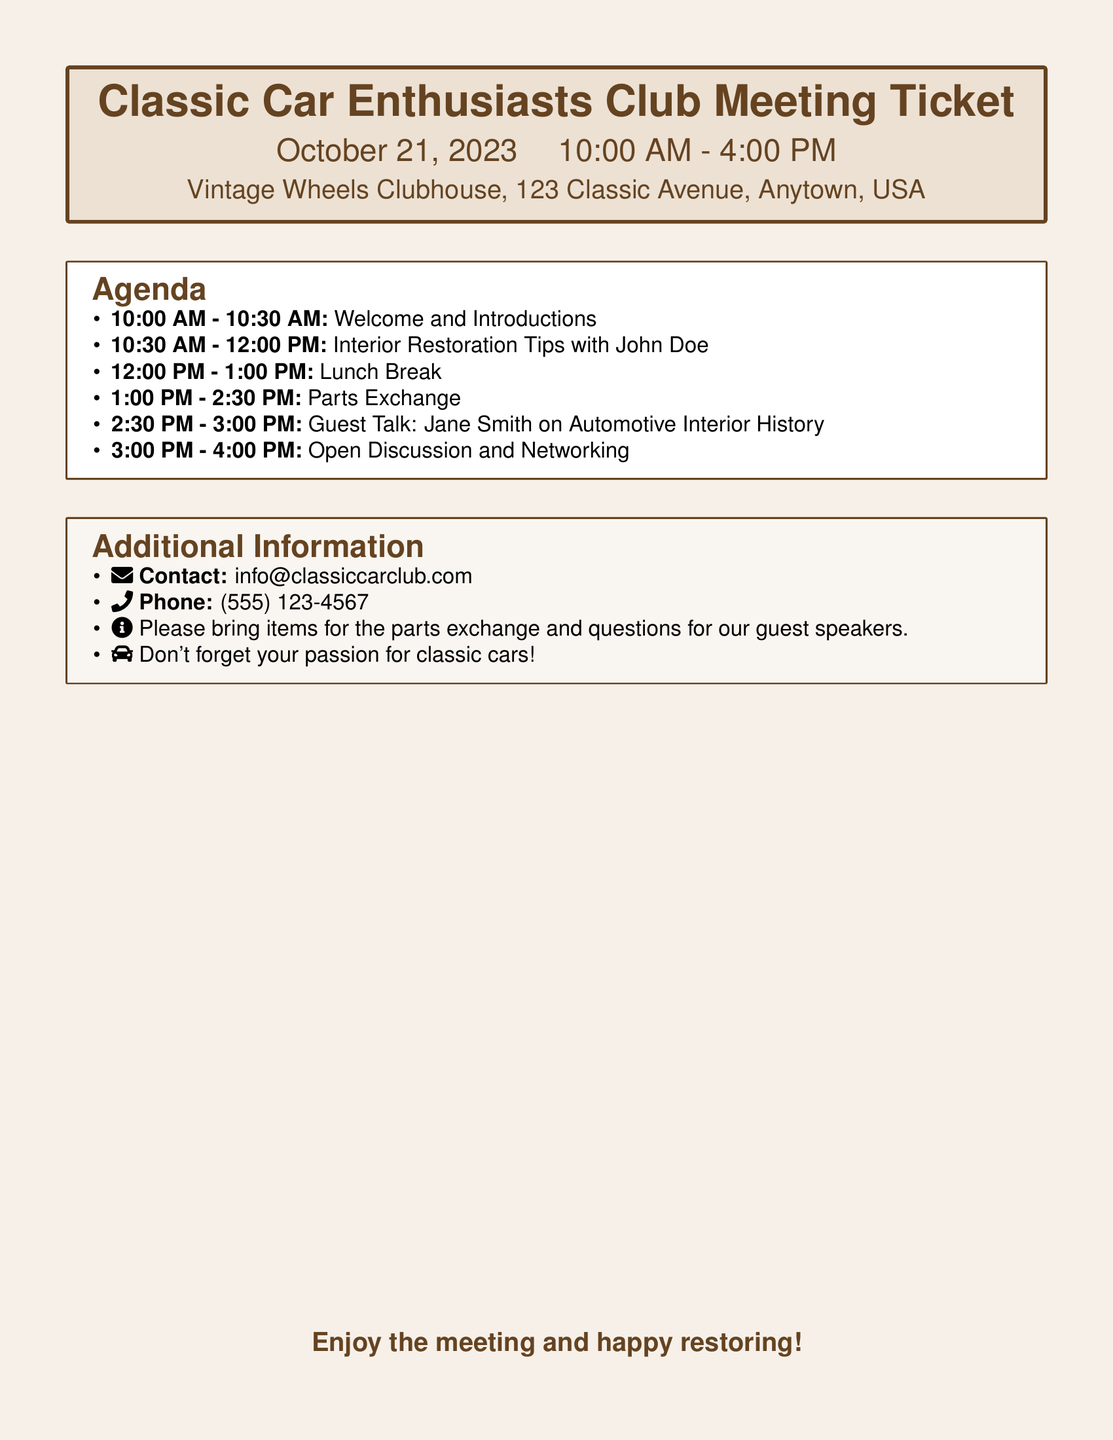what date is the meeting scheduled for? The meeting date is mentioned at the beginning of the document, specifically stated as October 21, 2023.
Answer: October 21, 2023 what time does the meeting start? The start time is indicated in the first section of the document, listed as 10:00 AM.
Answer: 10:00 AM who is the guest speaker for the talk on automotive interior history? The guest speaker's name for the talk is provided in the agenda section, which mentions Jane Smith.
Answer: Jane Smith how long is the lunch break? The duration of the lunch break is specified in the agenda, showing it lasts for one hour.
Answer: 1 hour what is one item to bring for the parts exchange? The document mentions to bring items for the parts exchange in the additional information section.
Answer: items for the parts exchange what is the location of the meeting? The location is provided in the introductory section, specifically found as Vintage Wheels Clubhouse, 123 Classic Avenue, Anytown, USA.
Answer: Vintage Wheels Clubhouse, 123 Classic Avenue, Anytown, USA what is the main topic of the session from 10:30 AM to 12:00 PM? The main topic during that session time is mentioned as Interior Restoration Tips with John Doe in the agenda.
Answer: Interior Restoration Tips with John Doe how long is the open discussion and networking session? The duration of the open discussion and networking is specified in the agenda, lasting for one hour.
Answer: 1 hour 